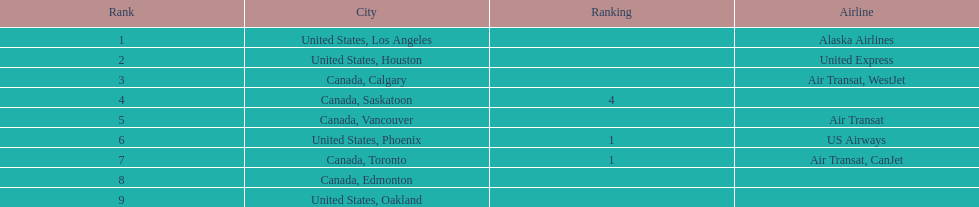How many airlines have a steady ranking? 4. 